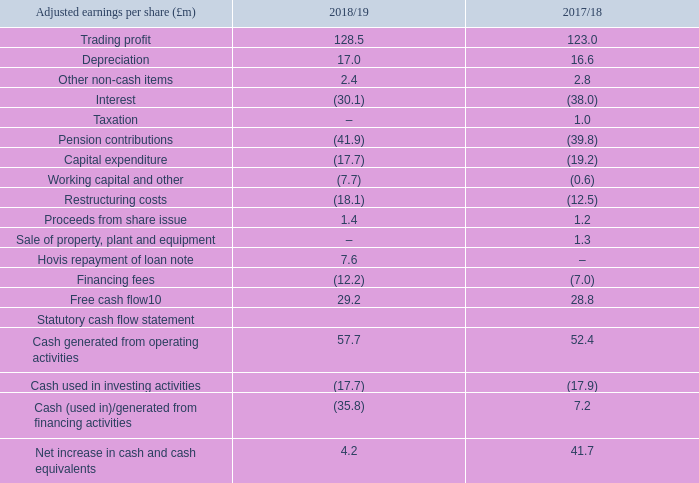Free cash flow
The Group reported an inflow of Free cash in the period of £29.2m. Trading profit of £128.5m was £5.5m ahead of the prior year for the reasons outlined above, while depreciation of £17.0m was slightly higher than 2017/18. Other non-cash items of £2.4m was predominantly due to share based payments.
Net interest paid was £7.9m lower in the year at £30.1m, reflecting the timing of interest payable on the £300m fixed rate notes due October 2023 which were issued in the first half of the year. This is a one-off benefit to cash interest paid; in 2019/20 cash interest is expected to be in the range of £35-39m. No taxation was paid in the period due to the availability of brought forward losses and capital allowances, however, a payment of £1.0m was received in the prior period from Irish tax authorities in respect of tax paid in prior years.
Pension contributions in the year were £41.9m, in line with expectations, and £2.1m higher than the prior year. Pension deficit contribution payments made to the Premier Foods pension schemes of £34.9m were the largest component of cash paid in the year; the balance being expenses connected to administering both the RHM and Premier Foods schemes and government levies. Pension deficit contribution payments in 2019/20 are expected to be £37m and administration and government levy costs approximately £6-8m.
Capital expenditure was £17.7m in the year, £1.5m lower than the prior year. In 2019/20, the Group expects to increase its capital expenditure to circa £25m to fund investment in both growth projects supporting the Group’s innovation strategy and cost release projects to deliver efficiency savings. For example, the Group is investing in one of its lines at its Stoke cake manufacturing site which will provide enhanced and varied product innovation capabilities.
Working capital investment was £7.7m in the year compared to £0.6m in 2017/18. Part of this movement reflected higher stock levels in anticipation of the original planned date to leave the European Union to protect the Company against the risk of delays at ports.
Restructuring costs were £18.1m compared to £12.5m in the comparative period. These were predominantly associated with implementation costs of the Group’s logistics transformation programme and also advisory costs connected with the potential disposal of the Ambrosia brand which has since concluded.
Financing fees of £12.2m relate to costs associated with the extension of the Group’s revolving credit facility and the issue of new £300m Senior secured fixed rate notes early in the financial year. This comprised £5.6m due to the early redemption of previously issued fixed rate notes due March 2021 and £6.6m of other fees associated with the issue of the new fixed rate notes and extension of the Group’s revolving credit facility.
The Group received a partial repayment of its loan note and associated interest from Hovis of £7.6m in the year. There is the possibility of the Group receiving a second tranche during 2019/20.
On a statutory basis, cash generated from operations was £80.2m compared to £89.4m in 2017/18. Cash generated from operating activities was £57.7m in the year after deducting net interest paid of £22.5m, which includes the partial repayment of the loan note from Hovis as described above. Cash used in investing activities was £17.7m in 2018/19 compared to £17.9m in the prior year. Cash used in financing activities was £35.8m in the year versus £7.2m cash generated in 2017/18. This was due to the repayment of the £325m fixed rate notes due March 2021, partly offset by proceeds received from the issue of £300m floating rate notes due October 2023 and the payment of financing fees as described above.
At 30 March 2019, the Group held cash and bank deposits of £27.8m compared to £23.6m at 31 March 2018 and the Group’s revolving credit facility was undrawn.
What is the trading profit in 2018/19?
Answer scale should be: million. 128.5. What is the trading profit in 2017/18?
Answer scale should be: million. 123.0. What is the depreciation in 2017/18?
Answer scale should be: million. 16.6. What was the change in the trading profit from 2017/18 to 2018/19?
Answer scale should be: million. 128.5 - 123.0
Answer: 5.5. What was the average depreciation for 2017/18 and 2018/19?
Answer scale should be: million. (17.0 + 16.6) / 2
Answer: 16.8. What is the average other non-cash items for 2017/18 and 2018/19?
Answer scale should be: million. (2.4 + 2.8) / 2 
Answer: 2.6. 